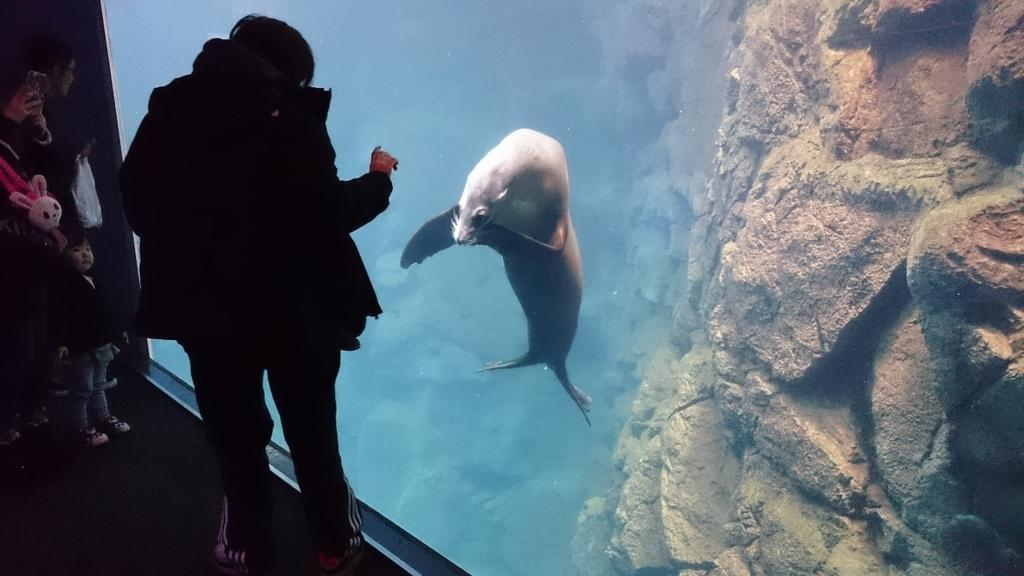How many people are in the image? There are people in the image, but the exact number is not specified. What are some of the people doing in the image? Some people are holding objects in the image. What is in the water in the image? There is a shark in the water in the image. What can be seen on the right side of the image? The right side of the image includes a wall. What type of beam is being used to support the hose in the image? There is no beam or hose present in the image. How many people are resting on the wall in the image? There is no indication that people are resting on the wall in the image. 